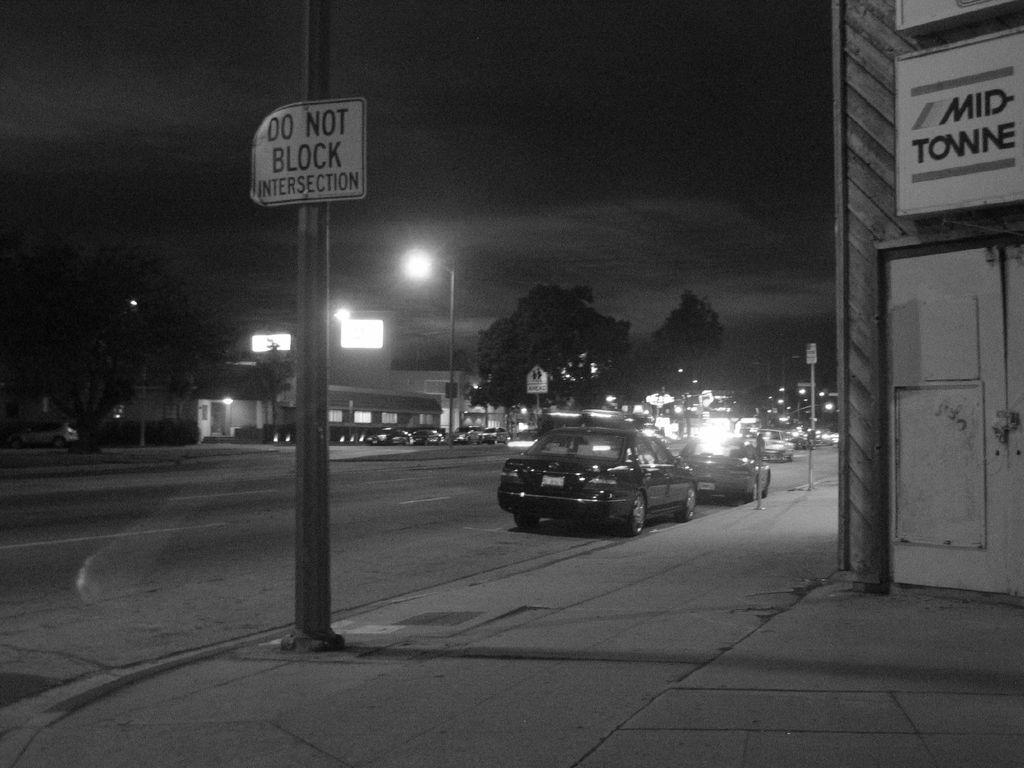How would you summarize this image in a sentence or two? This image is taken outdoors. This image is a black and white image. At the bottom of the image there is a sidewalk. At the top of the image there is the sky with clouds. In the background there are a few trees. There is a house and there are a few lights. Many vehicles are parked on the road and a few are moving on the road. There is a signboard. In the middle of the image there is a pole and there is a board with a text on it. On the right side of the image there is a building with a wall, a door and there is a board with a text on it. 